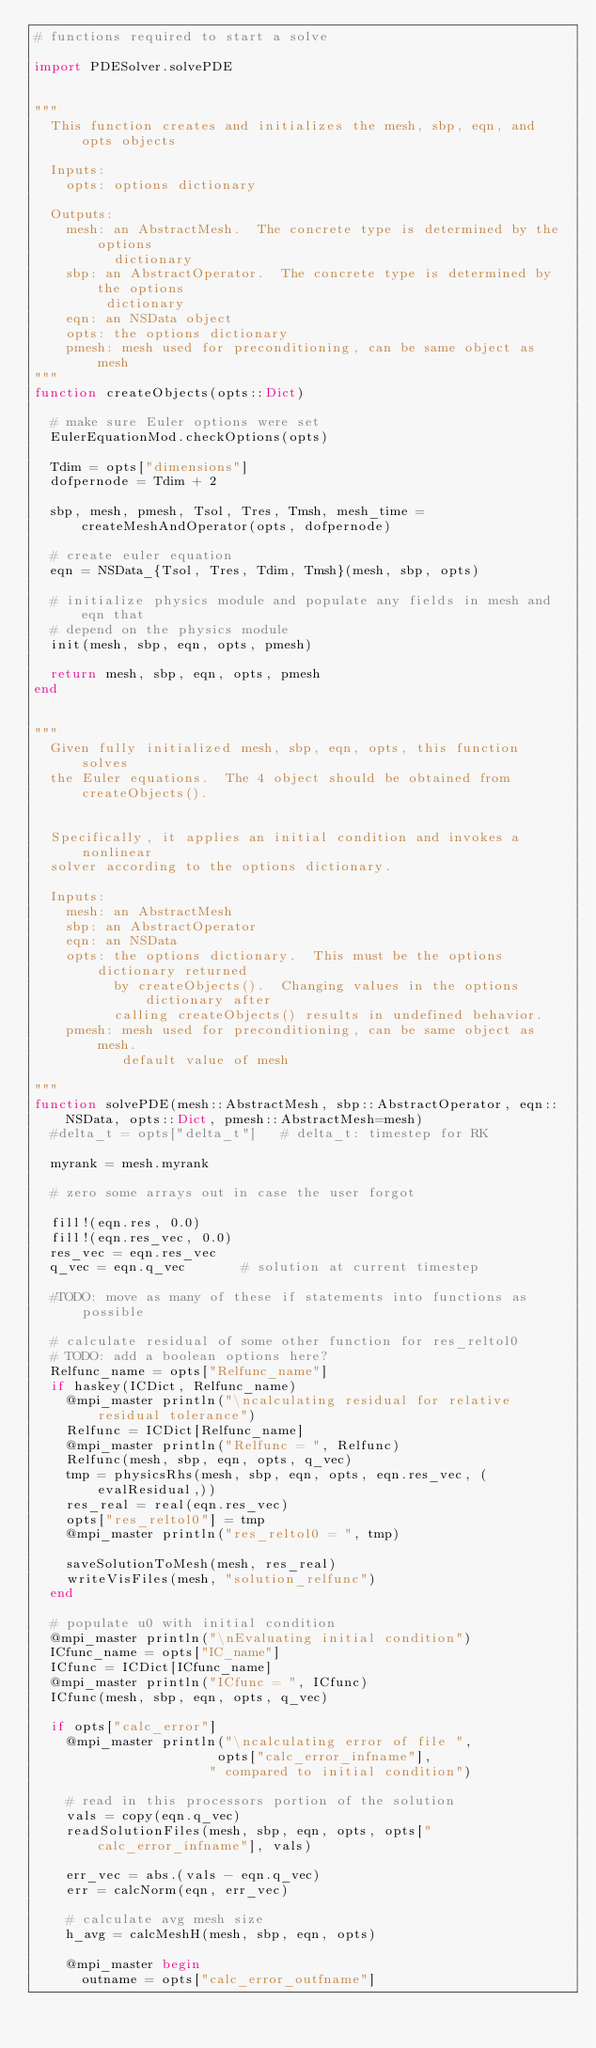Convert code to text. <code><loc_0><loc_0><loc_500><loc_500><_Julia_># functions required to start a solve

import PDESolver.solvePDE


"""
  This function creates and initializes the mesh, sbp, eqn, and opts objects

  Inputs:
    opts: options dictionary

  Outputs:
    mesh: an AbstractMesh.  The concrete type is determined by the options
          dictionary
    sbp: an AbstractOperator.  The concrete type is determined by the options
         dictionary
    eqn: an NSData object
    opts: the options dictionary
    pmesh: mesh used for preconditioning, can be same object as mesh
"""
function createObjects(opts::Dict)

  # make sure Euler options were set
  EulerEquationMod.checkOptions(opts)

  Tdim = opts["dimensions"]
  dofpernode = Tdim + 2

  sbp, mesh, pmesh, Tsol, Tres, Tmsh, mesh_time = createMeshAndOperator(opts, dofpernode)

  # create euler equation
  eqn = NSData_{Tsol, Tres, Tdim, Tmsh}(mesh, sbp, opts)

  # initialize physics module and populate any fields in mesh and eqn that
  # depend on the physics module
  init(mesh, sbp, eqn, opts, pmesh)

  return mesh, sbp, eqn, opts, pmesh
end


"""
  Given fully initialized mesh, sbp, eqn, opts, this function solves
  the Euler equations.  The 4 object should be obtained from createObjects().


  Specifically, it applies an initial condition and invokes a nonlinear
  solver according to the options dictionary.

  Inputs:
    mesh: an AbstractMesh
    sbp: an AbstractOperator
    eqn: an NSData
    opts: the options dictionary.  This must be the options dictionary returned
          by createObjects().  Changing values in the options dictionary after
          calling createObjects() results in undefined behavior.
    pmesh: mesh used for preconditioning, can be same object as mesh.
           default value of mesh

"""
function solvePDE(mesh::AbstractMesh, sbp::AbstractOperator, eqn::NSData, opts::Dict, pmesh::AbstractMesh=mesh)
  #delta_t = opts["delta_t"]   # delta_t: timestep for RK

  myrank = mesh.myrank

  # zero some arrays out in case the user forgot

  fill!(eqn.res, 0.0)
  fill!(eqn.res_vec, 0.0)
  res_vec = eqn.res_vec
  q_vec = eqn.q_vec       # solution at current timestep

  #TODO: move as many of these if statements into functions as possible

  # calculate residual of some other function for res_reltol0
  # TODO: add a boolean options here?
  Relfunc_name = opts["Relfunc_name"]
  if haskey(ICDict, Relfunc_name)
    @mpi_master println("\ncalculating residual for relative residual tolerance")
    Relfunc = ICDict[Relfunc_name]
    @mpi_master println("Relfunc = ", Relfunc)
    Relfunc(mesh, sbp, eqn, opts, q_vec)
    tmp = physicsRhs(mesh, sbp, eqn, opts, eqn.res_vec, (evalResidual,))
    res_real = real(eqn.res_vec)
    opts["res_reltol0"] = tmp
    @mpi_master println("res_reltol0 = ", tmp)

    saveSolutionToMesh(mesh, res_real)
    writeVisFiles(mesh, "solution_relfunc")
  end

  # populate u0 with initial condition
  @mpi_master println("\nEvaluating initial condition")
  ICfunc_name = opts["IC_name"]
  ICfunc = ICDict[ICfunc_name]
  @mpi_master println("ICfunc = ", ICfunc)
  ICfunc(mesh, sbp, eqn, opts, q_vec)

  if opts["calc_error"]
    @mpi_master println("\ncalculating error of file ",
                       opts["calc_error_infname"],
                      " compared to initial condition")

    # read in this processors portion of the solution
    vals = copy(eqn.q_vec)
    readSolutionFiles(mesh, sbp, eqn, opts, opts["calc_error_infname"], vals)

    err_vec = abs.(vals - eqn.q_vec)
    err = calcNorm(eqn, err_vec)

    # calculate avg mesh size
    h_avg = calcMeshH(mesh, sbp, eqn, opts)

    @mpi_master begin
      outname = opts["calc_error_outfname"]</code> 